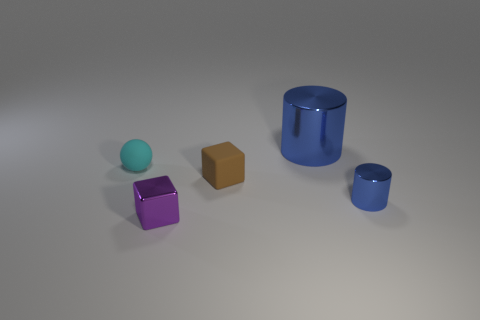Add 2 brown matte cubes. How many objects exist? 7 Subtract all cylinders. How many objects are left? 3 Subtract all small metallic cylinders. Subtract all cyan matte spheres. How many objects are left? 3 Add 1 cyan matte objects. How many cyan matte objects are left? 2 Add 4 tiny purple blocks. How many tiny purple blocks exist? 5 Subtract 0 purple balls. How many objects are left? 5 